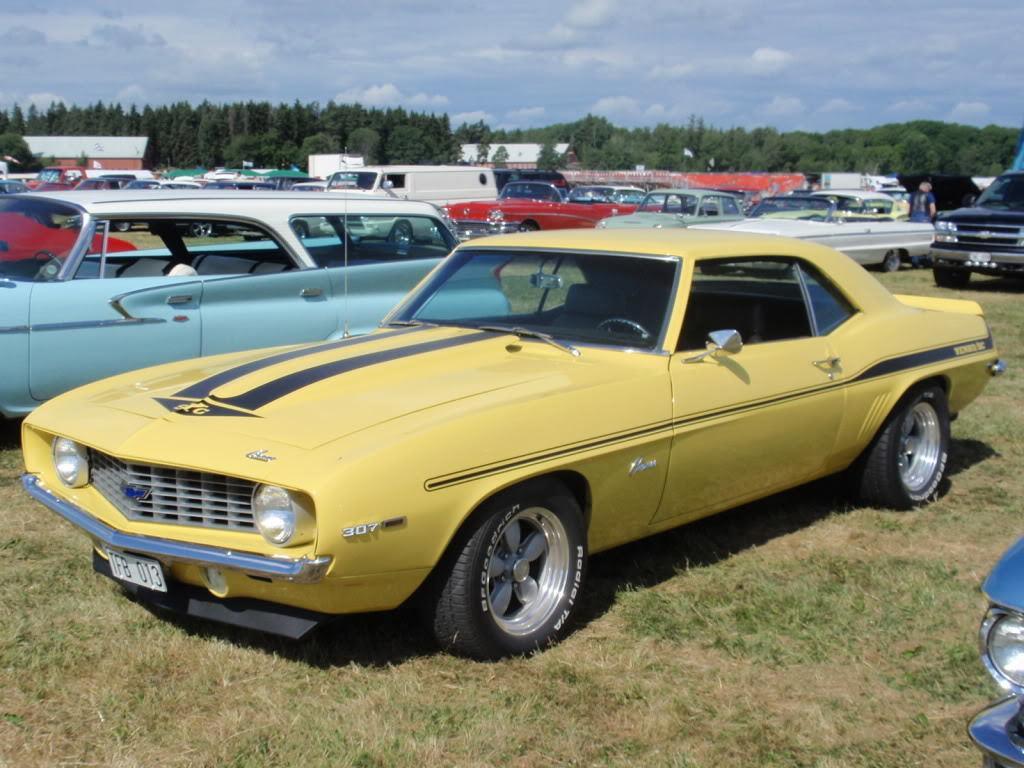In one or two sentences, can you explain what this image depicts? As we can see in the image there is grass, different colors of cars and in the background there are trees. At the top there is sky and there are clouds. 